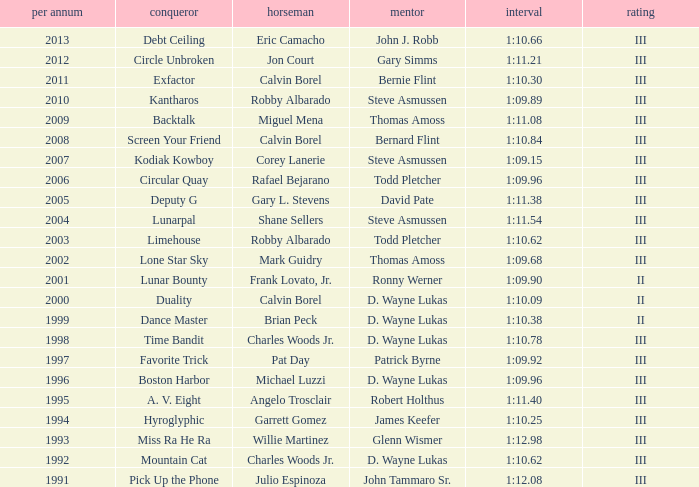Which trainer had a time of 1:10.09 with a year less than 2009? D. Wayne Lukas. 